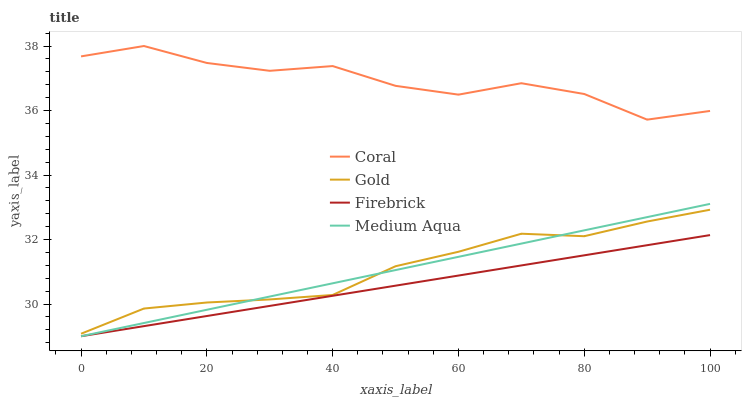Does Firebrick have the minimum area under the curve?
Answer yes or no. Yes. Does Coral have the maximum area under the curve?
Answer yes or no. Yes. Does Medium Aqua have the minimum area under the curve?
Answer yes or no. No. Does Medium Aqua have the maximum area under the curve?
Answer yes or no. No. Is Medium Aqua the smoothest?
Answer yes or no. Yes. Is Coral the roughest?
Answer yes or no. Yes. Is Firebrick the smoothest?
Answer yes or no. No. Is Firebrick the roughest?
Answer yes or no. No. Does Medium Aqua have the lowest value?
Answer yes or no. Yes. Does Gold have the lowest value?
Answer yes or no. No. Does Coral have the highest value?
Answer yes or no. Yes. Does Medium Aqua have the highest value?
Answer yes or no. No. Is Firebrick less than Gold?
Answer yes or no. Yes. Is Coral greater than Medium Aqua?
Answer yes or no. Yes. Does Gold intersect Medium Aqua?
Answer yes or no. Yes. Is Gold less than Medium Aqua?
Answer yes or no. No. Is Gold greater than Medium Aqua?
Answer yes or no. No. Does Firebrick intersect Gold?
Answer yes or no. No. 